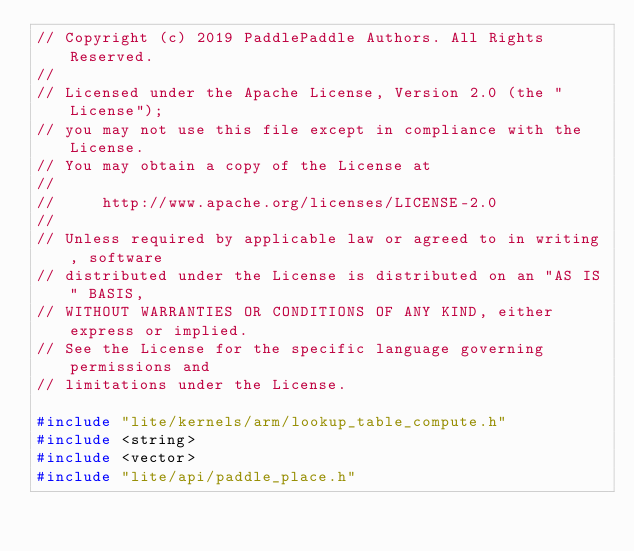Convert code to text. <code><loc_0><loc_0><loc_500><loc_500><_C++_>// Copyright (c) 2019 PaddlePaddle Authors. All Rights Reserved.
//
// Licensed under the Apache License, Version 2.0 (the "License");
// you may not use this file except in compliance with the License.
// You may obtain a copy of the License at
//
//     http://www.apache.org/licenses/LICENSE-2.0
//
// Unless required by applicable law or agreed to in writing, software
// distributed under the License is distributed on an "AS IS" BASIS,
// WITHOUT WARRANTIES OR CONDITIONS OF ANY KIND, either express or implied.
// See the License for the specific language governing permissions and
// limitations under the License.

#include "lite/kernels/arm/lookup_table_compute.h"
#include <string>
#include <vector>
#include "lite/api/paddle_place.h"</code> 